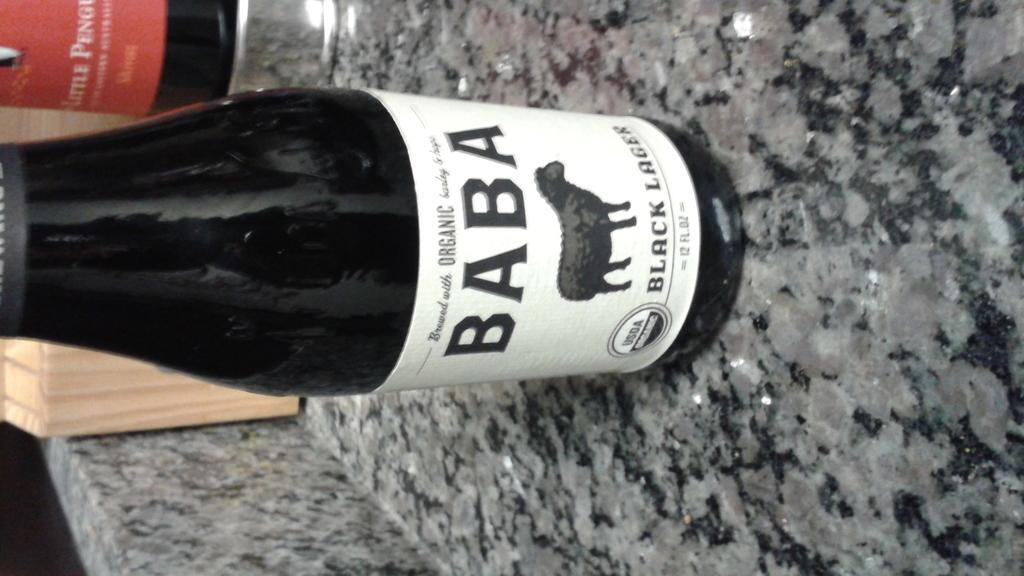How many ounces is this beer?
Offer a very short reply. 12. 